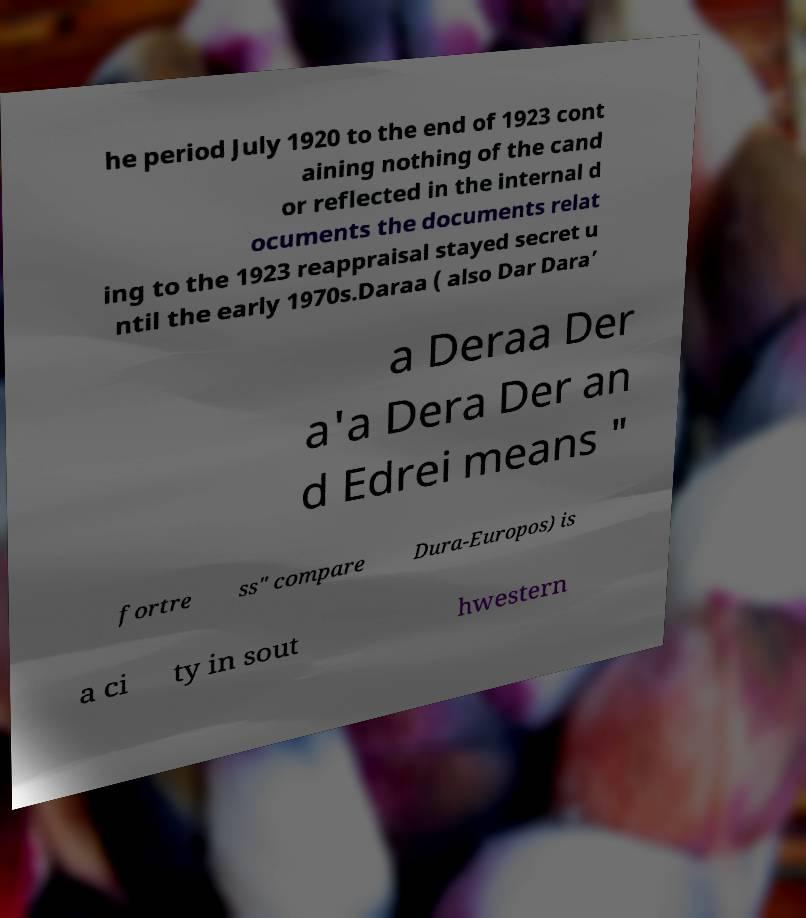Can you accurately transcribe the text from the provided image for me? he period July 1920 to the end of 1923 cont aining nothing of the cand or reflected in the internal d ocuments the documents relat ing to the 1923 reappraisal stayed secret u ntil the early 1970s.Daraa ( also Dar Dara’ a Deraa Der a'a Dera Der an d Edrei means " fortre ss" compare Dura-Europos) is a ci ty in sout hwestern 